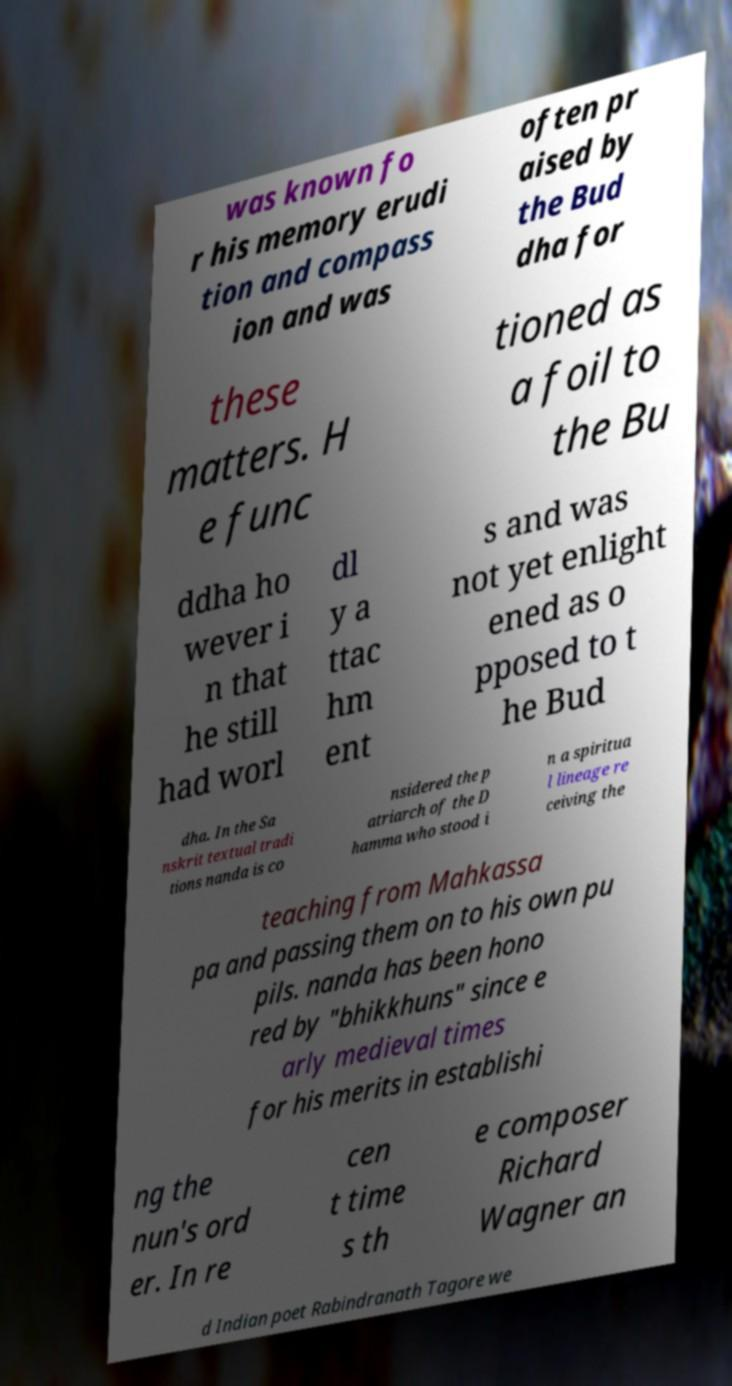I need the written content from this picture converted into text. Can you do that? was known fo r his memory erudi tion and compass ion and was often pr aised by the Bud dha for these matters. H e func tioned as a foil to the Bu ddha ho wever i n that he still had worl dl y a ttac hm ent s and was not yet enlight ened as o pposed to t he Bud dha. In the Sa nskrit textual tradi tions nanda is co nsidered the p atriarch of the D hamma who stood i n a spiritua l lineage re ceiving the teaching from Mahkassa pa and passing them on to his own pu pils. nanda has been hono red by "bhikkhuns" since e arly medieval times for his merits in establishi ng the nun's ord er. In re cen t time s th e composer Richard Wagner an d Indian poet Rabindranath Tagore we 